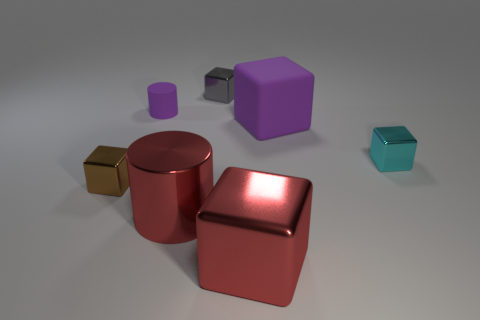Subtract all tiny cyan metal cubes. How many cubes are left? 4 Subtract all gray blocks. How many blocks are left? 4 Add 1 red shiny blocks. How many objects exist? 8 Subtract all cylinders. How many objects are left? 5 Subtract 1 cubes. How many cubes are left? 4 Add 4 small cyan cubes. How many small cyan cubes are left? 5 Add 3 red cylinders. How many red cylinders exist? 4 Subtract 1 purple cylinders. How many objects are left? 6 Subtract all brown cylinders. Subtract all red cubes. How many cylinders are left? 2 Subtract all small gray rubber things. Subtract all tiny gray shiny cubes. How many objects are left? 6 